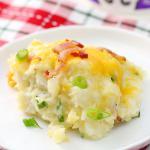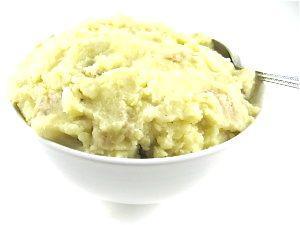The first image is the image on the left, the second image is the image on the right. Examine the images to the left and right. Is the description "One of the dishes of potatoes has a utensil stuck into the food." accurate? Answer yes or no. Yes. The first image is the image on the left, the second image is the image on the right. Considering the images on both sides, is "There is a white plate of mashed potatoes and gravy in the image on the left." valid? Answer yes or no. No. 